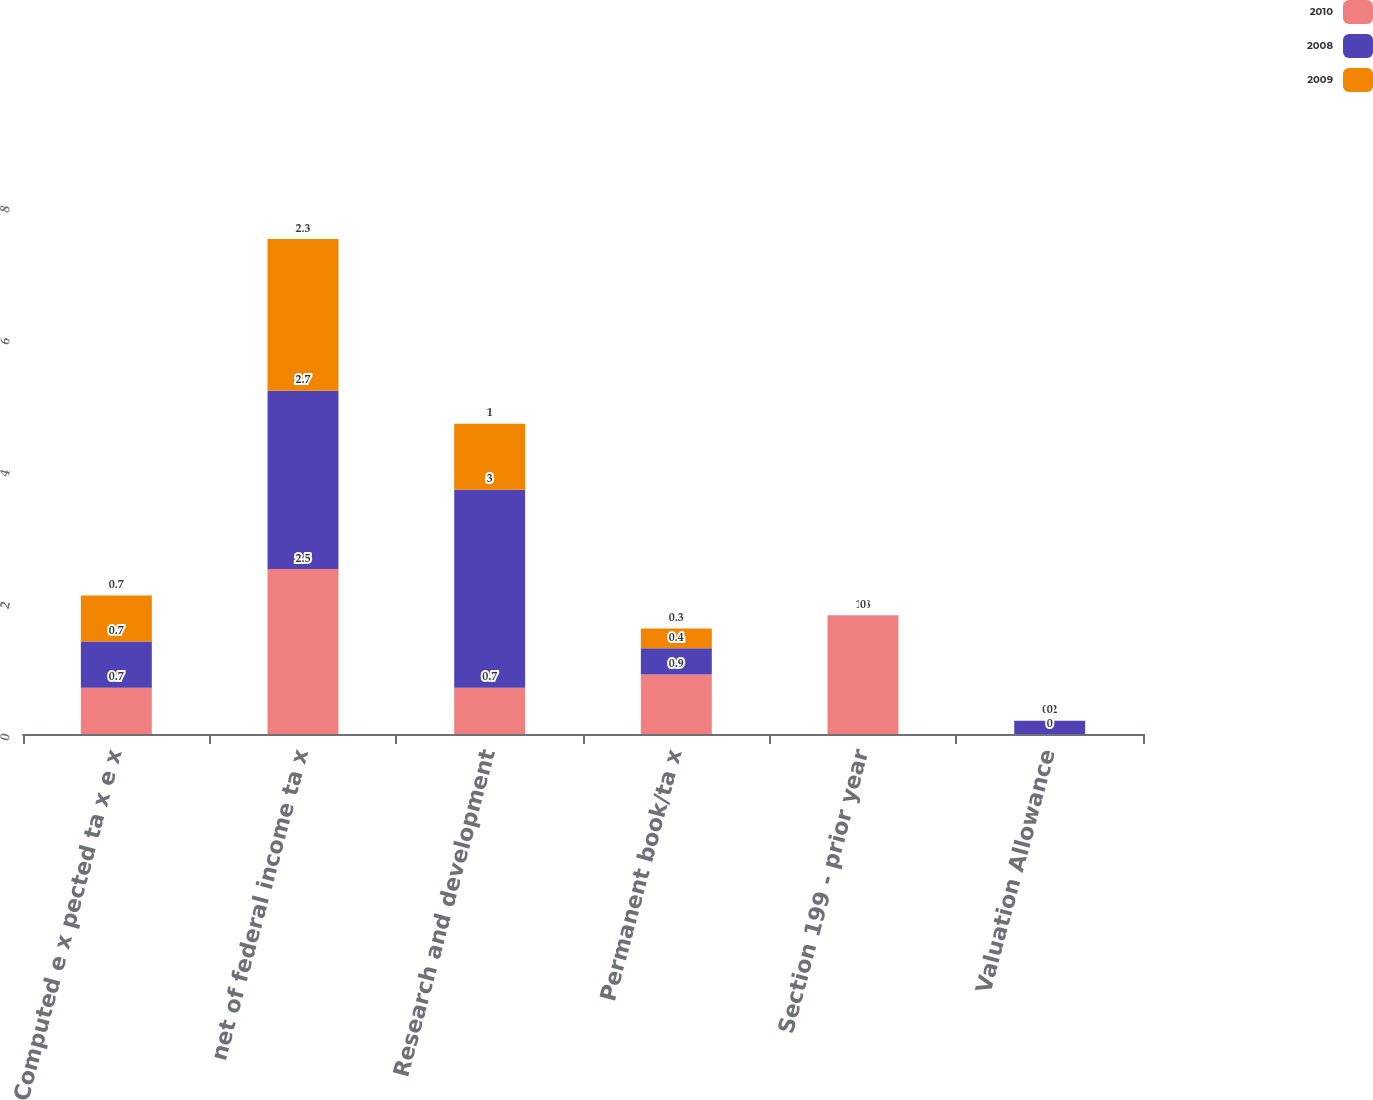Convert chart to OTSL. <chart><loc_0><loc_0><loc_500><loc_500><stacked_bar_chart><ecel><fcel>Computed e x pected ta x e x<fcel>net of federal income ta x<fcel>Research and development<fcel>Permanent book/ta x<fcel>Section 199 - prior year<fcel>Valuation Allowance<nl><fcel>2010<fcel>0.7<fcel>2.5<fcel>0.7<fcel>0.9<fcel>1.8<fcel>0<nl><fcel>2008<fcel>0.7<fcel>2.7<fcel>3<fcel>0.4<fcel>0<fcel>0.2<nl><fcel>2009<fcel>0.7<fcel>2.3<fcel>1<fcel>0.3<fcel>0<fcel>0<nl></chart> 